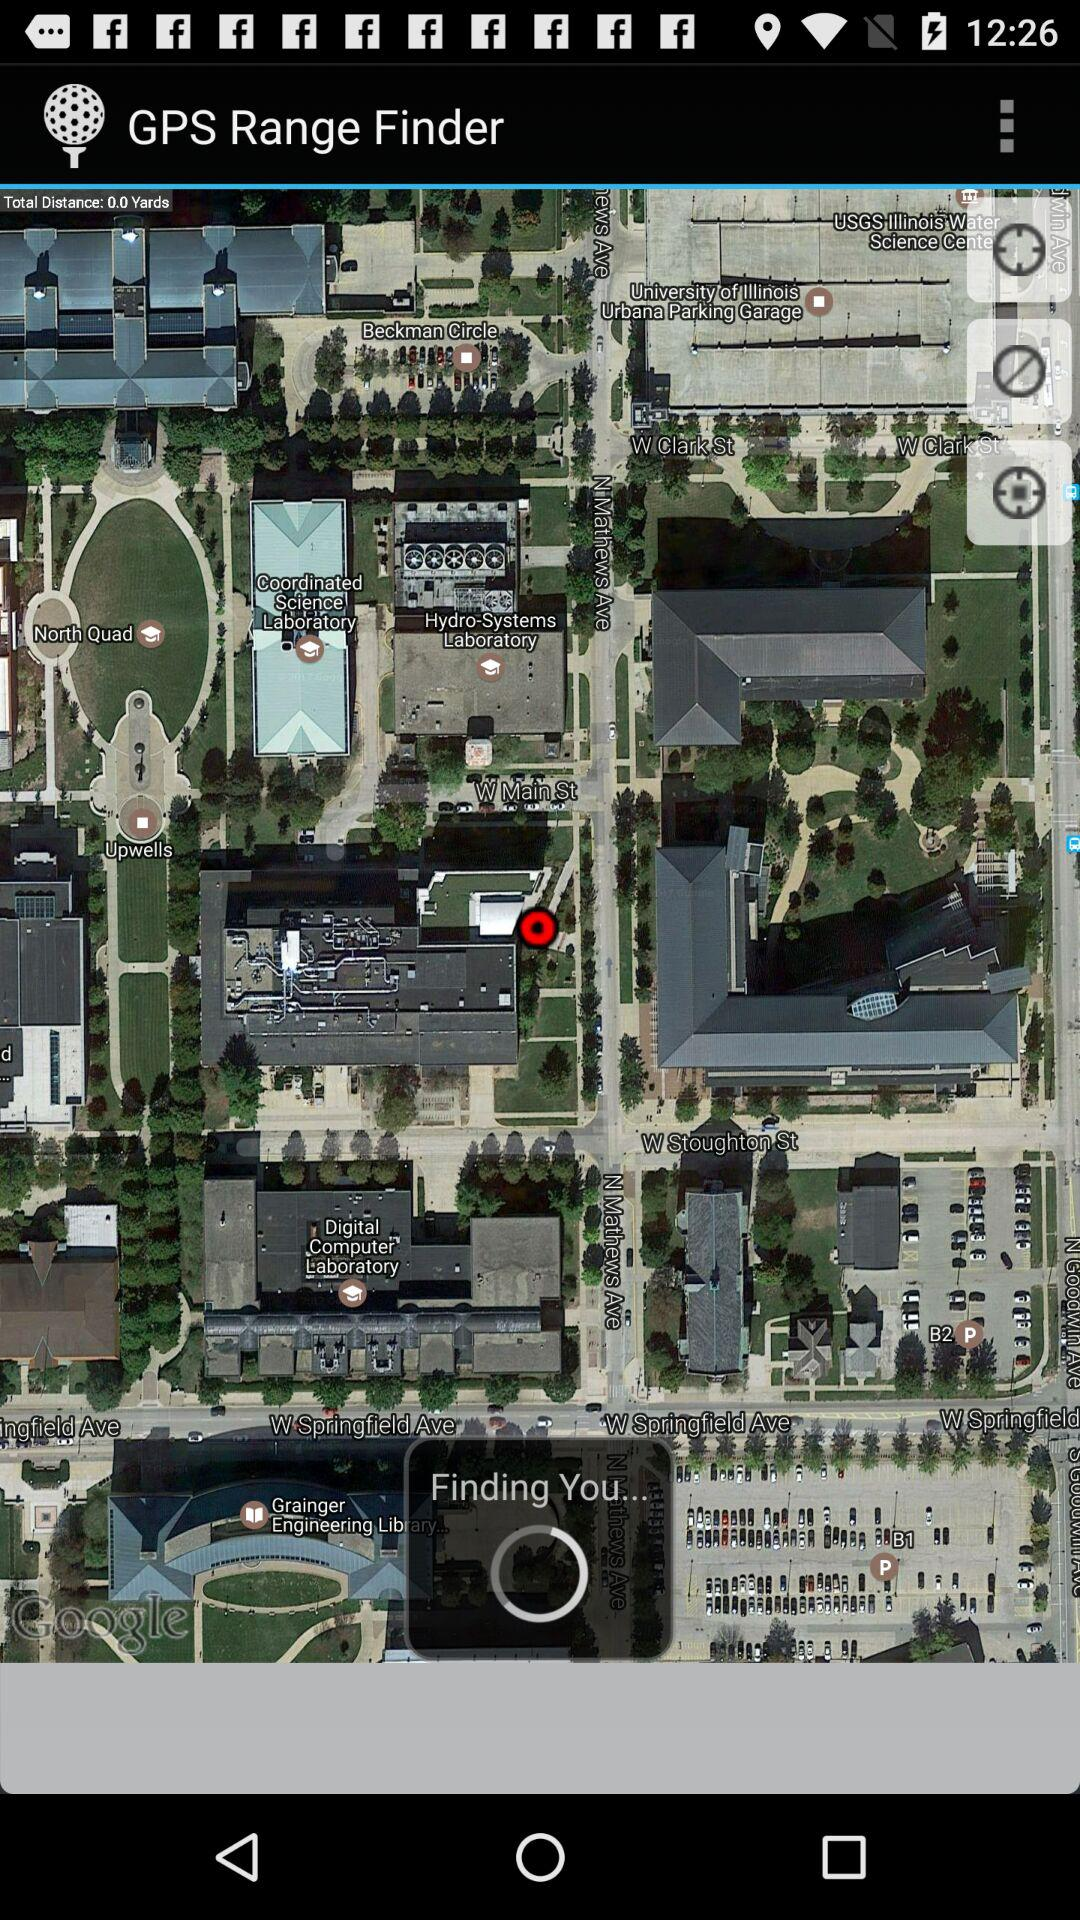What version of "GPS Range Finder" is being used?
When the provided information is insufficient, respond with <no answer>. <no answer> 